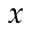Convert formula to latex. <formula><loc_0><loc_0><loc_500><loc_500>x</formula> 